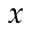Convert formula to latex. <formula><loc_0><loc_0><loc_500><loc_500>x</formula> 